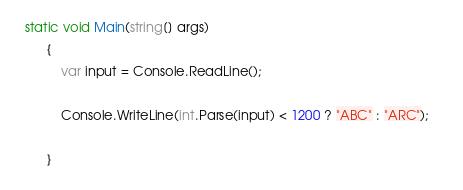<code> <loc_0><loc_0><loc_500><loc_500><_C#_>  static void Main(string[] args)
        {
            var input = Console.ReadLine();                                                   

            Console.WriteLine(int.Parse(input) < 1200 ? "ABC" : "ARC");

        }</code> 